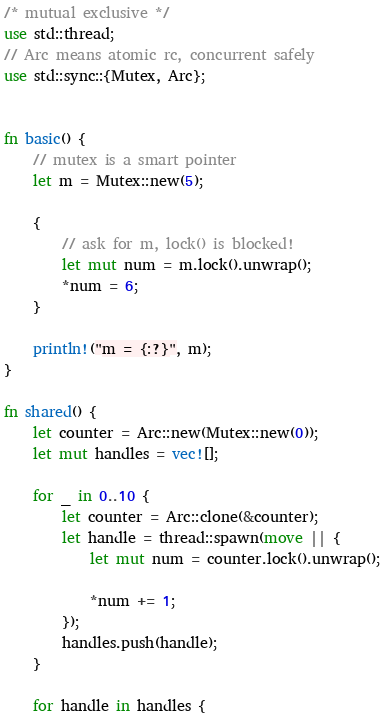Convert code to text. <code><loc_0><loc_0><loc_500><loc_500><_Rust_>/* mutual exclusive */
use std::thread;
// Arc means atomic rc, concurrent safely
use std::sync::{Mutex, Arc};


fn basic() {
    // mutex is a smart pointer
    let m = Mutex::new(5);

    {
        // ask for m, lock() is blocked!
        let mut num = m.lock().unwrap();
        *num = 6;
    }

    println!("m = {:?}", m);
}

fn shared() {
    let counter = Arc::new(Mutex::new(0));
    let mut handles = vec![];

    for _ in 0..10 {
        let counter = Arc::clone(&counter);
        let handle = thread::spawn(move || {
            let mut num = counter.lock().unwrap();

            *num += 1;
        });
        handles.push(handle);
    }

    for handle in handles {</code> 